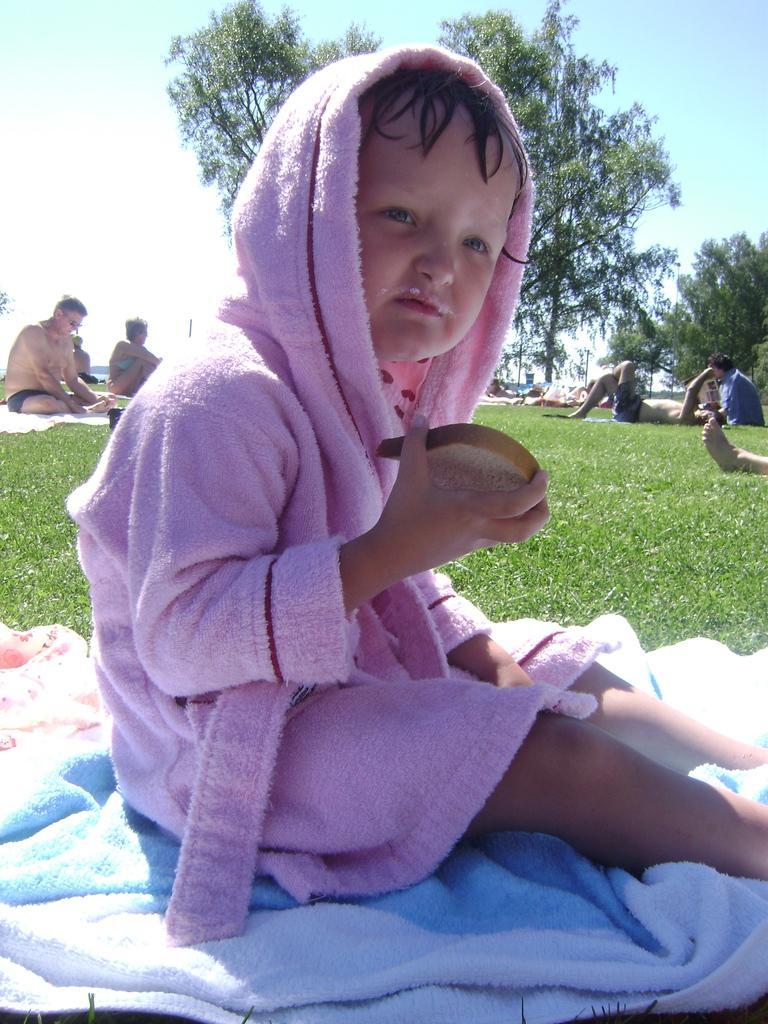Please provide a concise description of this image. This image is clicked outside. There are trees at the top. There is sky at the top. There are so many persons sitting on grass. In the front there is a kid who is wearing a bathrobe. He is holding a bread in his hand. 